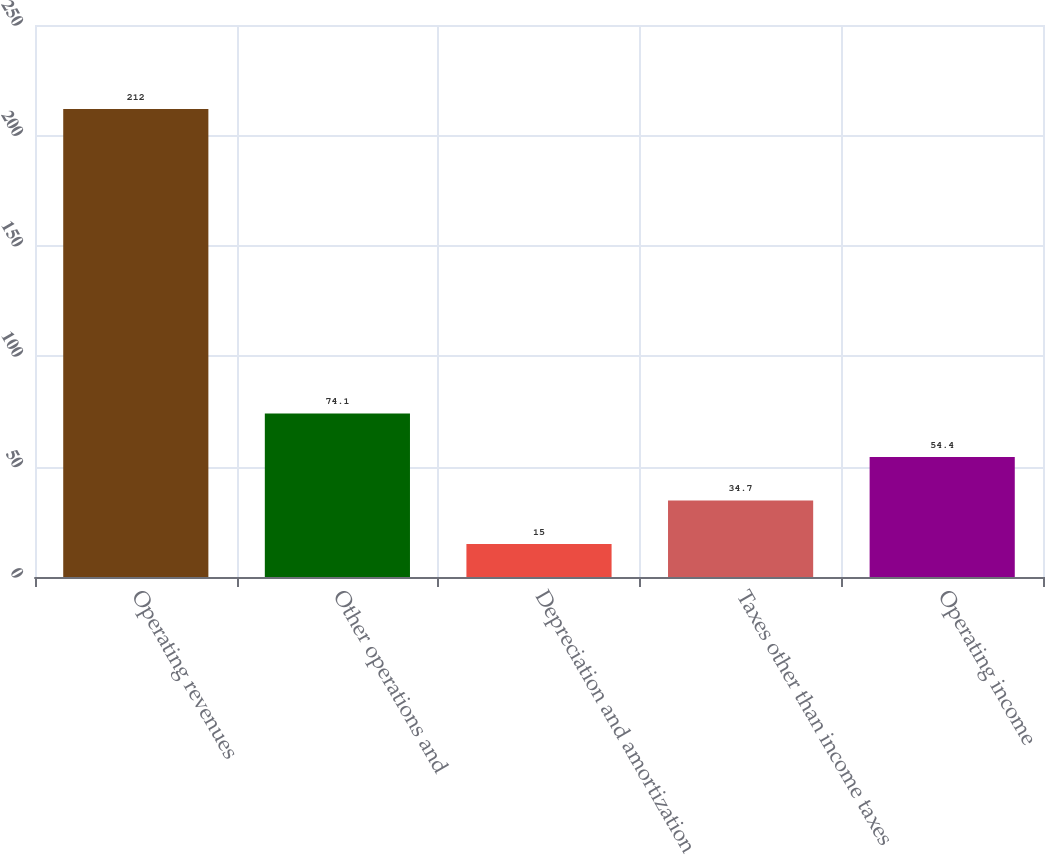<chart> <loc_0><loc_0><loc_500><loc_500><bar_chart><fcel>Operating revenues<fcel>Other operations and<fcel>Depreciation and amortization<fcel>Taxes other than income taxes<fcel>Operating income<nl><fcel>212<fcel>74.1<fcel>15<fcel>34.7<fcel>54.4<nl></chart> 